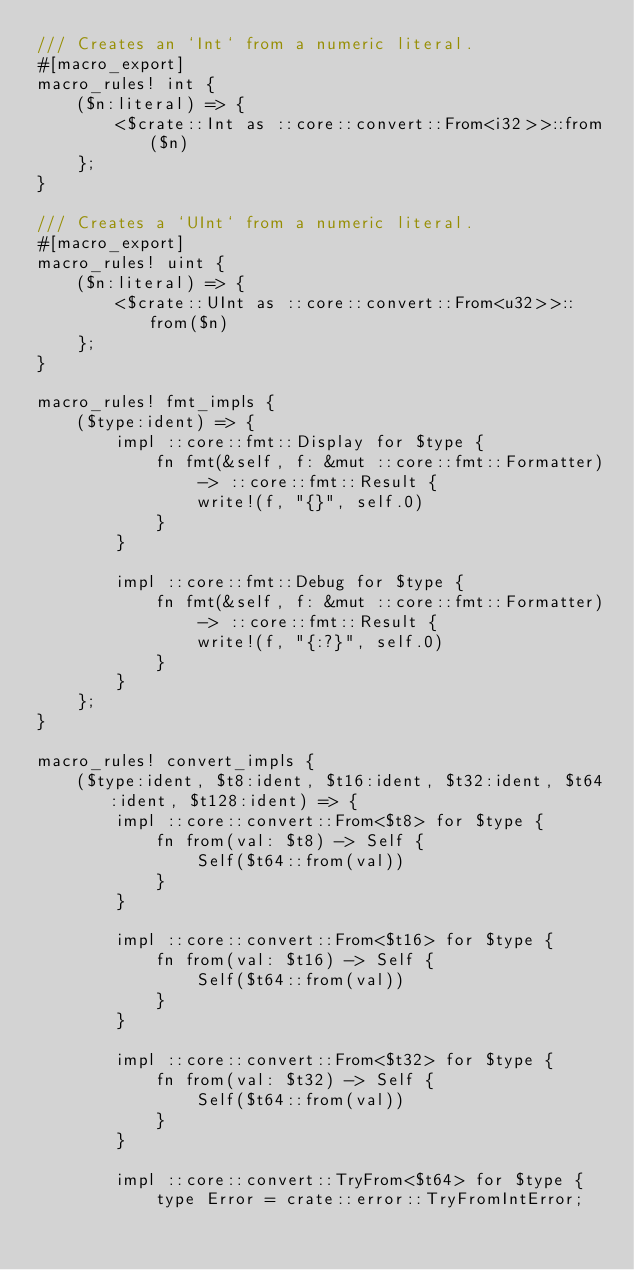Convert code to text. <code><loc_0><loc_0><loc_500><loc_500><_Rust_>/// Creates an `Int` from a numeric literal.
#[macro_export]
macro_rules! int {
    ($n:literal) => {
        <$crate::Int as ::core::convert::From<i32>>::from($n)
    };
}

/// Creates a `UInt` from a numeric literal.
#[macro_export]
macro_rules! uint {
    ($n:literal) => {
        <$crate::UInt as ::core::convert::From<u32>>::from($n)
    };
}

macro_rules! fmt_impls {
    ($type:ident) => {
        impl ::core::fmt::Display for $type {
            fn fmt(&self, f: &mut ::core::fmt::Formatter) -> ::core::fmt::Result {
                write!(f, "{}", self.0)
            }
        }

        impl ::core::fmt::Debug for $type {
            fn fmt(&self, f: &mut ::core::fmt::Formatter) -> ::core::fmt::Result {
                write!(f, "{:?}", self.0)
            }
        }
    };
}

macro_rules! convert_impls {
    ($type:ident, $t8:ident, $t16:ident, $t32:ident, $t64:ident, $t128:ident) => {
        impl ::core::convert::From<$t8> for $type {
            fn from(val: $t8) -> Self {
                Self($t64::from(val))
            }
        }

        impl ::core::convert::From<$t16> for $type {
            fn from(val: $t16) -> Self {
                Self($t64::from(val))
            }
        }

        impl ::core::convert::From<$t32> for $type {
            fn from(val: $t32) -> Self {
                Self($t64::from(val))
            }
        }

        impl ::core::convert::TryFrom<$t64> for $type {
            type Error = crate::error::TryFromIntError;
</code> 